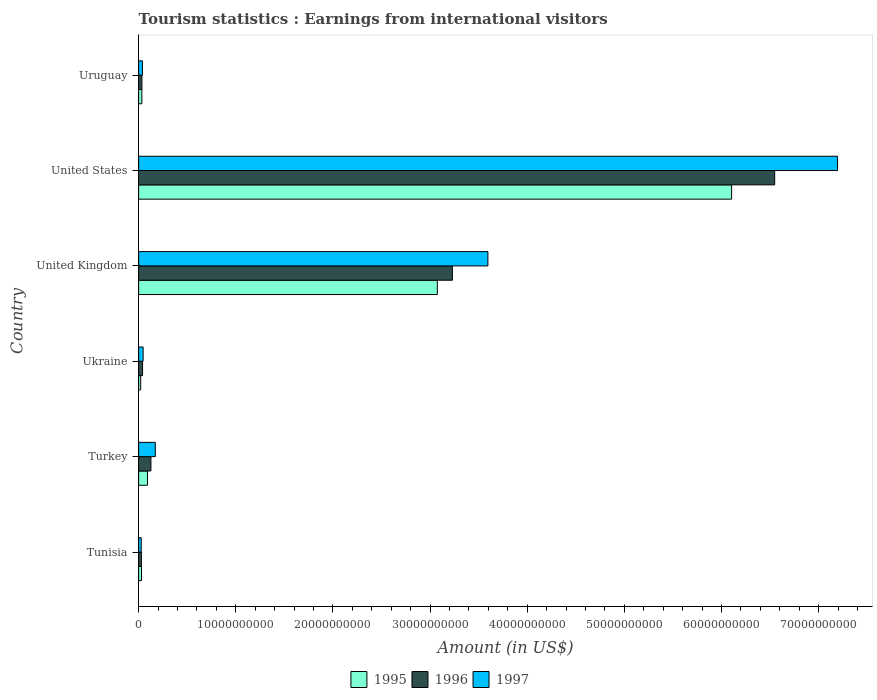How many different coloured bars are there?
Make the answer very short. 3. How many bars are there on the 3rd tick from the top?
Your answer should be very brief. 3. How many bars are there on the 4th tick from the bottom?
Offer a terse response. 3. What is the label of the 4th group of bars from the top?
Offer a terse response. Ukraine. What is the earnings from international visitors in 1996 in United States?
Ensure brevity in your answer.  6.55e+1. Across all countries, what is the maximum earnings from international visitors in 1996?
Offer a very short reply. 6.55e+1. Across all countries, what is the minimum earnings from international visitors in 1997?
Ensure brevity in your answer.  2.66e+08. In which country was the earnings from international visitors in 1996 minimum?
Ensure brevity in your answer.  Tunisia. What is the total earnings from international visitors in 1995 in the graph?
Provide a short and direct response. 9.35e+1. What is the difference between the earnings from international visitors in 1997 in United Kingdom and that in Uruguay?
Make the answer very short. 3.56e+1. What is the difference between the earnings from international visitors in 1996 in Tunisia and the earnings from international visitors in 1997 in Turkey?
Offer a very short reply. -1.43e+09. What is the average earnings from international visitors in 1996 per country?
Ensure brevity in your answer.  1.67e+1. What is the difference between the earnings from international visitors in 1996 and earnings from international visitors in 1997 in Ukraine?
Provide a short and direct response. -5.70e+07. What is the ratio of the earnings from international visitors in 1996 in Turkey to that in United States?
Your response must be concise. 0.02. What is the difference between the highest and the second highest earnings from international visitors in 1995?
Provide a succinct answer. 3.03e+1. What is the difference between the highest and the lowest earnings from international visitors in 1995?
Offer a terse response. 6.08e+1. In how many countries, is the earnings from international visitors in 1996 greater than the average earnings from international visitors in 1996 taken over all countries?
Keep it short and to the point. 2. What does the 3rd bar from the bottom in United States represents?
Offer a terse response. 1997. Is it the case that in every country, the sum of the earnings from international visitors in 1997 and earnings from international visitors in 1995 is greater than the earnings from international visitors in 1996?
Ensure brevity in your answer.  Yes. How many countries are there in the graph?
Keep it short and to the point. 6. Are the values on the major ticks of X-axis written in scientific E-notation?
Your answer should be compact. No. Does the graph contain any zero values?
Ensure brevity in your answer.  No. Where does the legend appear in the graph?
Make the answer very short. Bottom center. How many legend labels are there?
Keep it short and to the point. 3. How are the legend labels stacked?
Make the answer very short. Horizontal. What is the title of the graph?
Provide a succinct answer. Tourism statistics : Earnings from international visitors. What is the label or title of the X-axis?
Make the answer very short. Amount (in US$). What is the label or title of the Y-axis?
Your answer should be very brief. Country. What is the Amount (in US$) in 1995 in Tunisia?
Provide a short and direct response. 2.94e+08. What is the Amount (in US$) in 1996 in Tunisia?
Make the answer very short. 2.82e+08. What is the Amount (in US$) of 1997 in Tunisia?
Provide a short and direct response. 2.66e+08. What is the Amount (in US$) in 1995 in Turkey?
Keep it short and to the point. 9.11e+08. What is the Amount (in US$) of 1996 in Turkey?
Offer a very short reply. 1.26e+09. What is the Amount (in US$) in 1997 in Turkey?
Your answer should be very brief. 1.72e+09. What is the Amount (in US$) of 1995 in Ukraine?
Provide a succinct answer. 2.10e+08. What is the Amount (in US$) in 1996 in Ukraine?
Provide a succinct answer. 4.05e+08. What is the Amount (in US$) in 1997 in Ukraine?
Your answer should be compact. 4.62e+08. What is the Amount (in US$) in 1995 in United Kingdom?
Offer a very short reply. 3.07e+1. What is the Amount (in US$) of 1996 in United Kingdom?
Provide a short and direct response. 3.23e+1. What is the Amount (in US$) of 1997 in United Kingdom?
Make the answer very short. 3.60e+1. What is the Amount (in US$) in 1995 in United States?
Provide a short and direct response. 6.10e+1. What is the Amount (in US$) in 1996 in United States?
Offer a terse response. 6.55e+1. What is the Amount (in US$) in 1997 in United States?
Make the answer very short. 7.19e+1. What is the Amount (in US$) in 1995 in Uruguay?
Ensure brevity in your answer.  3.32e+08. What is the Amount (in US$) in 1996 in Uruguay?
Ensure brevity in your answer.  3.39e+08. What is the Amount (in US$) of 1997 in Uruguay?
Give a very brief answer. 3.91e+08. Across all countries, what is the maximum Amount (in US$) in 1995?
Keep it short and to the point. 6.10e+1. Across all countries, what is the maximum Amount (in US$) in 1996?
Provide a short and direct response. 6.55e+1. Across all countries, what is the maximum Amount (in US$) in 1997?
Keep it short and to the point. 7.19e+1. Across all countries, what is the minimum Amount (in US$) of 1995?
Your response must be concise. 2.10e+08. Across all countries, what is the minimum Amount (in US$) of 1996?
Your answer should be very brief. 2.82e+08. Across all countries, what is the minimum Amount (in US$) of 1997?
Your answer should be compact. 2.66e+08. What is the total Amount (in US$) of 1995 in the graph?
Offer a very short reply. 9.35e+1. What is the total Amount (in US$) in 1996 in the graph?
Your answer should be compact. 1.00e+11. What is the total Amount (in US$) in 1997 in the graph?
Offer a very short reply. 1.11e+11. What is the difference between the Amount (in US$) in 1995 in Tunisia and that in Turkey?
Provide a succinct answer. -6.17e+08. What is the difference between the Amount (in US$) in 1996 in Tunisia and that in Turkey?
Your answer should be compact. -9.83e+08. What is the difference between the Amount (in US$) in 1997 in Tunisia and that in Turkey?
Your response must be concise. -1.45e+09. What is the difference between the Amount (in US$) of 1995 in Tunisia and that in Ukraine?
Provide a short and direct response. 8.40e+07. What is the difference between the Amount (in US$) of 1996 in Tunisia and that in Ukraine?
Make the answer very short. -1.23e+08. What is the difference between the Amount (in US$) in 1997 in Tunisia and that in Ukraine?
Provide a succinct answer. -1.96e+08. What is the difference between the Amount (in US$) of 1995 in Tunisia and that in United Kingdom?
Provide a short and direct response. -3.05e+1. What is the difference between the Amount (in US$) of 1996 in Tunisia and that in United Kingdom?
Provide a short and direct response. -3.20e+1. What is the difference between the Amount (in US$) of 1997 in Tunisia and that in United Kingdom?
Ensure brevity in your answer.  -3.57e+1. What is the difference between the Amount (in US$) of 1995 in Tunisia and that in United States?
Provide a succinct answer. -6.07e+1. What is the difference between the Amount (in US$) in 1996 in Tunisia and that in United States?
Keep it short and to the point. -6.52e+1. What is the difference between the Amount (in US$) of 1997 in Tunisia and that in United States?
Your answer should be compact. -7.17e+1. What is the difference between the Amount (in US$) of 1995 in Tunisia and that in Uruguay?
Provide a succinct answer. -3.80e+07. What is the difference between the Amount (in US$) of 1996 in Tunisia and that in Uruguay?
Your response must be concise. -5.70e+07. What is the difference between the Amount (in US$) in 1997 in Tunisia and that in Uruguay?
Your response must be concise. -1.25e+08. What is the difference between the Amount (in US$) of 1995 in Turkey and that in Ukraine?
Give a very brief answer. 7.01e+08. What is the difference between the Amount (in US$) of 1996 in Turkey and that in Ukraine?
Your answer should be very brief. 8.60e+08. What is the difference between the Amount (in US$) in 1997 in Turkey and that in Ukraine?
Give a very brief answer. 1.25e+09. What is the difference between the Amount (in US$) of 1995 in Turkey and that in United Kingdom?
Provide a succinct answer. -2.98e+1. What is the difference between the Amount (in US$) of 1996 in Turkey and that in United Kingdom?
Offer a very short reply. -3.10e+1. What is the difference between the Amount (in US$) in 1997 in Turkey and that in United Kingdom?
Your answer should be very brief. -3.42e+1. What is the difference between the Amount (in US$) of 1995 in Turkey and that in United States?
Offer a very short reply. -6.01e+1. What is the difference between the Amount (in US$) of 1996 in Turkey and that in United States?
Your answer should be very brief. -6.42e+1. What is the difference between the Amount (in US$) of 1997 in Turkey and that in United States?
Provide a succinct answer. -7.02e+1. What is the difference between the Amount (in US$) in 1995 in Turkey and that in Uruguay?
Provide a short and direct response. 5.79e+08. What is the difference between the Amount (in US$) in 1996 in Turkey and that in Uruguay?
Ensure brevity in your answer.  9.26e+08. What is the difference between the Amount (in US$) in 1997 in Turkey and that in Uruguay?
Offer a terse response. 1.32e+09. What is the difference between the Amount (in US$) in 1995 in Ukraine and that in United Kingdom?
Your answer should be very brief. -3.05e+1. What is the difference between the Amount (in US$) in 1996 in Ukraine and that in United Kingdom?
Make the answer very short. -3.19e+1. What is the difference between the Amount (in US$) of 1997 in Ukraine and that in United Kingdom?
Provide a succinct answer. -3.55e+1. What is the difference between the Amount (in US$) of 1995 in Ukraine and that in United States?
Keep it short and to the point. -6.08e+1. What is the difference between the Amount (in US$) of 1996 in Ukraine and that in United States?
Your answer should be very brief. -6.51e+1. What is the difference between the Amount (in US$) of 1997 in Ukraine and that in United States?
Provide a succinct answer. -7.15e+1. What is the difference between the Amount (in US$) of 1995 in Ukraine and that in Uruguay?
Provide a succinct answer. -1.22e+08. What is the difference between the Amount (in US$) of 1996 in Ukraine and that in Uruguay?
Your response must be concise. 6.60e+07. What is the difference between the Amount (in US$) of 1997 in Ukraine and that in Uruguay?
Your response must be concise. 7.10e+07. What is the difference between the Amount (in US$) of 1995 in United Kingdom and that in United States?
Ensure brevity in your answer.  -3.03e+1. What is the difference between the Amount (in US$) in 1996 in United Kingdom and that in United States?
Your response must be concise. -3.32e+1. What is the difference between the Amount (in US$) in 1997 in United Kingdom and that in United States?
Ensure brevity in your answer.  -3.60e+1. What is the difference between the Amount (in US$) of 1995 in United Kingdom and that in Uruguay?
Your answer should be compact. 3.04e+1. What is the difference between the Amount (in US$) of 1996 in United Kingdom and that in Uruguay?
Ensure brevity in your answer.  3.20e+1. What is the difference between the Amount (in US$) in 1997 in United Kingdom and that in Uruguay?
Give a very brief answer. 3.56e+1. What is the difference between the Amount (in US$) of 1995 in United States and that in Uruguay?
Give a very brief answer. 6.07e+1. What is the difference between the Amount (in US$) of 1996 in United States and that in Uruguay?
Offer a terse response. 6.51e+1. What is the difference between the Amount (in US$) of 1997 in United States and that in Uruguay?
Offer a terse response. 7.16e+1. What is the difference between the Amount (in US$) in 1995 in Tunisia and the Amount (in US$) in 1996 in Turkey?
Your answer should be very brief. -9.71e+08. What is the difference between the Amount (in US$) of 1995 in Tunisia and the Amount (in US$) of 1997 in Turkey?
Your answer should be compact. -1.42e+09. What is the difference between the Amount (in US$) in 1996 in Tunisia and the Amount (in US$) in 1997 in Turkey?
Your answer should be very brief. -1.43e+09. What is the difference between the Amount (in US$) in 1995 in Tunisia and the Amount (in US$) in 1996 in Ukraine?
Your answer should be compact. -1.11e+08. What is the difference between the Amount (in US$) of 1995 in Tunisia and the Amount (in US$) of 1997 in Ukraine?
Your answer should be compact. -1.68e+08. What is the difference between the Amount (in US$) of 1996 in Tunisia and the Amount (in US$) of 1997 in Ukraine?
Give a very brief answer. -1.80e+08. What is the difference between the Amount (in US$) of 1995 in Tunisia and the Amount (in US$) of 1996 in United Kingdom?
Your answer should be compact. -3.20e+1. What is the difference between the Amount (in US$) of 1995 in Tunisia and the Amount (in US$) of 1997 in United Kingdom?
Your response must be concise. -3.57e+1. What is the difference between the Amount (in US$) of 1996 in Tunisia and the Amount (in US$) of 1997 in United Kingdom?
Your response must be concise. -3.57e+1. What is the difference between the Amount (in US$) in 1995 in Tunisia and the Amount (in US$) in 1996 in United States?
Your response must be concise. -6.52e+1. What is the difference between the Amount (in US$) in 1995 in Tunisia and the Amount (in US$) in 1997 in United States?
Your response must be concise. -7.17e+1. What is the difference between the Amount (in US$) of 1996 in Tunisia and the Amount (in US$) of 1997 in United States?
Keep it short and to the point. -7.17e+1. What is the difference between the Amount (in US$) of 1995 in Tunisia and the Amount (in US$) of 1996 in Uruguay?
Provide a succinct answer. -4.50e+07. What is the difference between the Amount (in US$) in 1995 in Tunisia and the Amount (in US$) in 1997 in Uruguay?
Give a very brief answer. -9.70e+07. What is the difference between the Amount (in US$) of 1996 in Tunisia and the Amount (in US$) of 1997 in Uruguay?
Your response must be concise. -1.09e+08. What is the difference between the Amount (in US$) of 1995 in Turkey and the Amount (in US$) of 1996 in Ukraine?
Give a very brief answer. 5.06e+08. What is the difference between the Amount (in US$) in 1995 in Turkey and the Amount (in US$) in 1997 in Ukraine?
Your answer should be compact. 4.49e+08. What is the difference between the Amount (in US$) in 1996 in Turkey and the Amount (in US$) in 1997 in Ukraine?
Provide a short and direct response. 8.03e+08. What is the difference between the Amount (in US$) in 1995 in Turkey and the Amount (in US$) in 1996 in United Kingdom?
Offer a terse response. -3.14e+1. What is the difference between the Amount (in US$) of 1995 in Turkey and the Amount (in US$) of 1997 in United Kingdom?
Keep it short and to the point. -3.50e+1. What is the difference between the Amount (in US$) of 1996 in Turkey and the Amount (in US$) of 1997 in United Kingdom?
Offer a terse response. -3.47e+1. What is the difference between the Amount (in US$) of 1995 in Turkey and the Amount (in US$) of 1996 in United States?
Make the answer very short. -6.46e+1. What is the difference between the Amount (in US$) in 1995 in Turkey and the Amount (in US$) in 1997 in United States?
Ensure brevity in your answer.  -7.10e+1. What is the difference between the Amount (in US$) in 1996 in Turkey and the Amount (in US$) in 1997 in United States?
Give a very brief answer. -7.07e+1. What is the difference between the Amount (in US$) of 1995 in Turkey and the Amount (in US$) of 1996 in Uruguay?
Your answer should be very brief. 5.72e+08. What is the difference between the Amount (in US$) in 1995 in Turkey and the Amount (in US$) in 1997 in Uruguay?
Offer a terse response. 5.20e+08. What is the difference between the Amount (in US$) of 1996 in Turkey and the Amount (in US$) of 1997 in Uruguay?
Make the answer very short. 8.74e+08. What is the difference between the Amount (in US$) in 1995 in Ukraine and the Amount (in US$) in 1996 in United Kingdom?
Provide a short and direct response. -3.21e+1. What is the difference between the Amount (in US$) in 1995 in Ukraine and the Amount (in US$) in 1997 in United Kingdom?
Ensure brevity in your answer.  -3.57e+1. What is the difference between the Amount (in US$) in 1996 in Ukraine and the Amount (in US$) in 1997 in United Kingdom?
Your answer should be compact. -3.55e+1. What is the difference between the Amount (in US$) of 1995 in Ukraine and the Amount (in US$) of 1996 in United States?
Your response must be concise. -6.53e+1. What is the difference between the Amount (in US$) of 1995 in Ukraine and the Amount (in US$) of 1997 in United States?
Give a very brief answer. -7.17e+1. What is the difference between the Amount (in US$) of 1996 in Ukraine and the Amount (in US$) of 1997 in United States?
Give a very brief answer. -7.15e+1. What is the difference between the Amount (in US$) in 1995 in Ukraine and the Amount (in US$) in 1996 in Uruguay?
Make the answer very short. -1.29e+08. What is the difference between the Amount (in US$) of 1995 in Ukraine and the Amount (in US$) of 1997 in Uruguay?
Your answer should be compact. -1.81e+08. What is the difference between the Amount (in US$) in 1996 in Ukraine and the Amount (in US$) in 1997 in Uruguay?
Keep it short and to the point. 1.40e+07. What is the difference between the Amount (in US$) in 1995 in United Kingdom and the Amount (in US$) in 1996 in United States?
Make the answer very short. -3.47e+1. What is the difference between the Amount (in US$) in 1995 in United Kingdom and the Amount (in US$) in 1997 in United States?
Your answer should be very brief. -4.12e+1. What is the difference between the Amount (in US$) in 1996 in United Kingdom and the Amount (in US$) in 1997 in United States?
Your response must be concise. -3.97e+1. What is the difference between the Amount (in US$) of 1995 in United Kingdom and the Amount (in US$) of 1996 in Uruguay?
Your answer should be compact. 3.04e+1. What is the difference between the Amount (in US$) of 1995 in United Kingdom and the Amount (in US$) of 1997 in Uruguay?
Your response must be concise. 3.04e+1. What is the difference between the Amount (in US$) in 1996 in United Kingdom and the Amount (in US$) in 1997 in Uruguay?
Give a very brief answer. 3.19e+1. What is the difference between the Amount (in US$) of 1995 in United States and the Amount (in US$) of 1996 in Uruguay?
Make the answer very short. 6.07e+1. What is the difference between the Amount (in US$) in 1995 in United States and the Amount (in US$) in 1997 in Uruguay?
Provide a short and direct response. 6.07e+1. What is the difference between the Amount (in US$) of 1996 in United States and the Amount (in US$) of 1997 in Uruguay?
Make the answer very short. 6.51e+1. What is the average Amount (in US$) in 1995 per country?
Keep it short and to the point. 1.56e+1. What is the average Amount (in US$) in 1996 per country?
Keep it short and to the point. 1.67e+1. What is the average Amount (in US$) in 1997 per country?
Your response must be concise. 1.85e+1. What is the difference between the Amount (in US$) of 1995 and Amount (in US$) of 1996 in Tunisia?
Provide a succinct answer. 1.20e+07. What is the difference between the Amount (in US$) in 1995 and Amount (in US$) in 1997 in Tunisia?
Offer a very short reply. 2.80e+07. What is the difference between the Amount (in US$) in 1996 and Amount (in US$) in 1997 in Tunisia?
Give a very brief answer. 1.60e+07. What is the difference between the Amount (in US$) of 1995 and Amount (in US$) of 1996 in Turkey?
Ensure brevity in your answer.  -3.54e+08. What is the difference between the Amount (in US$) of 1995 and Amount (in US$) of 1997 in Turkey?
Give a very brief answer. -8.05e+08. What is the difference between the Amount (in US$) in 1996 and Amount (in US$) in 1997 in Turkey?
Your response must be concise. -4.51e+08. What is the difference between the Amount (in US$) of 1995 and Amount (in US$) of 1996 in Ukraine?
Offer a very short reply. -1.95e+08. What is the difference between the Amount (in US$) in 1995 and Amount (in US$) in 1997 in Ukraine?
Ensure brevity in your answer.  -2.52e+08. What is the difference between the Amount (in US$) in 1996 and Amount (in US$) in 1997 in Ukraine?
Make the answer very short. -5.70e+07. What is the difference between the Amount (in US$) in 1995 and Amount (in US$) in 1996 in United Kingdom?
Keep it short and to the point. -1.55e+09. What is the difference between the Amount (in US$) in 1995 and Amount (in US$) in 1997 in United Kingdom?
Ensure brevity in your answer.  -5.20e+09. What is the difference between the Amount (in US$) in 1996 and Amount (in US$) in 1997 in United Kingdom?
Your answer should be very brief. -3.66e+09. What is the difference between the Amount (in US$) in 1995 and Amount (in US$) in 1996 in United States?
Keep it short and to the point. -4.44e+09. What is the difference between the Amount (in US$) in 1995 and Amount (in US$) in 1997 in United States?
Offer a very short reply. -1.09e+1. What is the difference between the Amount (in US$) of 1996 and Amount (in US$) of 1997 in United States?
Offer a terse response. -6.47e+09. What is the difference between the Amount (in US$) of 1995 and Amount (in US$) of 1996 in Uruguay?
Make the answer very short. -7.00e+06. What is the difference between the Amount (in US$) of 1995 and Amount (in US$) of 1997 in Uruguay?
Ensure brevity in your answer.  -5.90e+07. What is the difference between the Amount (in US$) of 1996 and Amount (in US$) of 1997 in Uruguay?
Give a very brief answer. -5.20e+07. What is the ratio of the Amount (in US$) of 1995 in Tunisia to that in Turkey?
Make the answer very short. 0.32. What is the ratio of the Amount (in US$) of 1996 in Tunisia to that in Turkey?
Ensure brevity in your answer.  0.22. What is the ratio of the Amount (in US$) in 1997 in Tunisia to that in Turkey?
Provide a short and direct response. 0.15. What is the ratio of the Amount (in US$) of 1995 in Tunisia to that in Ukraine?
Give a very brief answer. 1.4. What is the ratio of the Amount (in US$) in 1996 in Tunisia to that in Ukraine?
Offer a terse response. 0.7. What is the ratio of the Amount (in US$) of 1997 in Tunisia to that in Ukraine?
Give a very brief answer. 0.58. What is the ratio of the Amount (in US$) of 1995 in Tunisia to that in United Kingdom?
Keep it short and to the point. 0.01. What is the ratio of the Amount (in US$) of 1996 in Tunisia to that in United Kingdom?
Offer a very short reply. 0.01. What is the ratio of the Amount (in US$) of 1997 in Tunisia to that in United Kingdom?
Ensure brevity in your answer.  0.01. What is the ratio of the Amount (in US$) in 1995 in Tunisia to that in United States?
Provide a succinct answer. 0. What is the ratio of the Amount (in US$) of 1996 in Tunisia to that in United States?
Provide a succinct answer. 0. What is the ratio of the Amount (in US$) in 1997 in Tunisia to that in United States?
Provide a short and direct response. 0. What is the ratio of the Amount (in US$) in 1995 in Tunisia to that in Uruguay?
Give a very brief answer. 0.89. What is the ratio of the Amount (in US$) in 1996 in Tunisia to that in Uruguay?
Your answer should be very brief. 0.83. What is the ratio of the Amount (in US$) in 1997 in Tunisia to that in Uruguay?
Your answer should be compact. 0.68. What is the ratio of the Amount (in US$) in 1995 in Turkey to that in Ukraine?
Make the answer very short. 4.34. What is the ratio of the Amount (in US$) of 1996 in Turkey to that in Ukraine?
Provide a short and direct response. 3.12. What is the ratio of the Amount (in US$) of 1997 in Turkey to that in Ukraine?
Keep it short and to the point. 3.71. What is the ratio of the Amount (in US$) in 1995 in Turkey to that in United Kingdom?
Provide a short and direct response. 0.03. What is the ratio of the Amount (in US$) in 1996 in Turkey to that in United Kingdom?
Your answer should be very brief. 0.04. What is the ratio of the Amount (in US$) of 1997 in Turkey to that in United Kingdom?
Offer a very short reply. 0.05. What is the ratio of the Amount (in US$) of 1995 in Turkey to that in United States?
Ensure brevity in your answer.  0.01. What is the ratio of the Amount (in US$) of 1996 in Turkey to that in United States?
Keep it short and to the point. 0.02. What is the ratio of the Amount (in US$) of 1997 in Turkey to that in United States?
Your answer should be compact. 0.02. What is the ratio of the Amount (in US$) of 1995 in Turkey to that in Uruguay?
Ensure brevity in your answer.  2.74. What is the ratio of the Amount (in US$) of 1996 in Turkey to that in Uruguay?
Make the answer very short. 3.73. What is the ratio of the Amount (in US$) in 1997 in Turkey to that in Uruguay?
Make the answer very short. 4.39. What is the ratio of the Amount (in US$) of 1995 in Ukraine to that in United Kingdom?
Provide a succinct answer. 0.01. What is the ratio of the Amount (in US$) in 1996 in Ukraine to that in United Kingdom?
Offer a terse response. 0.01. What is the ratio of the Amount (in US$) in 1997 in Ukraine to that in United Kingdom?
Ensure brevity in your answer.  0.01. What is the ratio of the Amount (in US$) in 1995 in Ukraine to that in United States?
Keep it short and to the point. 0. What is the ratio of the Amount (in US$) in 1996 in Ukraine to that in United States?
Offer a terse response. 0.01. What is the ratio of the Amount (in US$) in 1997 in Ukraine to that in United States?
Your answer should be very brief. 0.01. What is the ratio of the Amount (in US$) in 1995 in Ukraine to that in Uruguay?
Your answer should be very brief. 0.63. What is the ratio of the Amount (in US$) of 1996 in Ukraine to that in Uruguay?
Your answer should be compact. 1.19. What is the ratio of the Amount (in US$) of 1997 in Ukraine to that in Uruguay?
Your response must be concise. 1.18. What is the ratio of the Amount (in US$) of 1995 in United Kingdom to that in United States?
Offer a very short reply. 0.5. What is the ratio of the Amount (in US$) in 1996 in United Kingdom to that in United States?
Your answer should be very brief. 0.49. What is the ratio of the Amount (in US$) of 1997 in United Kingdom to that in United States?
Ensure brevity in your answer.  0.5. What is the ratio of the Amount (in US$) of 1995 in United Kingdom to that in Uruguay?
Your answer should be compact. 92.62. What is the ratio of the Amount (in US$) of 1996 in United Kingdom to that in Uruguay?
Provide a short and direct response. 95.27. What is the ratio of the Amount (in US$) of 1997 in United Kingdom to that in Uruguay?
Your answer should be compact. 91.95. What is the ratio of the Amount (in US$) in 1995 in United States to that in Uruguay?
Ensure brevity in your answer.  183.86. What is the ratio of the Amount (in US$) of 1996 in United States to that in Uruguay?
Make the answer very short. 193.15. What is the ratio of the Amount (in US$) in 1997 in United States to that in Uruguay?
Your answer should be very brief. 184.01. What is the difference between the highest and the second highest Amount (in US$) in 1995?
Give a very brief answer. 3.03e+1. What is the difference between the highest and the second highest Amount (in US$) of 1996?
Ensure brevity in your answer.  3.32e+1. What is the difference between the highest and the second highest Amount (in US$) of 1997?
Keep it short and to the point. 3.60e+1. What is the difference between the highest and the lowest Amount (in US$) of 1995?
Your response must be concise. 6.08e+1. What is the difference between the highest and the lowest Amount (in US$) in 1996?
Give a very brief answer. 6.52e+1. What is the difference between the highest and the lowest Amount (in US$) of 1997?
Ensure brevity in your answer.  7.17e+1. 